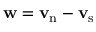<formula> <loc_0><loc_0><loc_500><loc_500>{ w } = { v _ { n } - v _ { s } }</formula> 